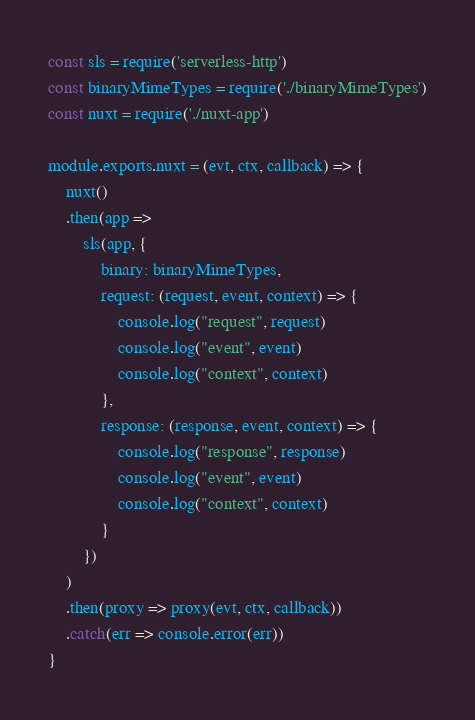Convert code to text. <code><loc_0><loc_0><loc_500><loc_500><_JavaScript_>const sls = require('serverless-http')
const binaryMimeTypes = require('./binaryMimeTypes')
const nuxt = require('./nuxt-app')

module.exports.nuxt = (evt, ctx, callback) => {
	nuxt()
	.then(app =>
		sls(app, {
			binary: binaryMimeTypes,
			request: (request, event, context) => {
				console.log("request", request)
				console.log("event", event)
				console.log("context", context)
			},
			response: (response, event, context) => {
				console.log("response", response)
				console.log("event", event)
				console.log("context", context)
			}
		})
	)
	.then(proxy => proxy(evt, ctx, callback))
	.catch(err => console.error(err))
}</code> 